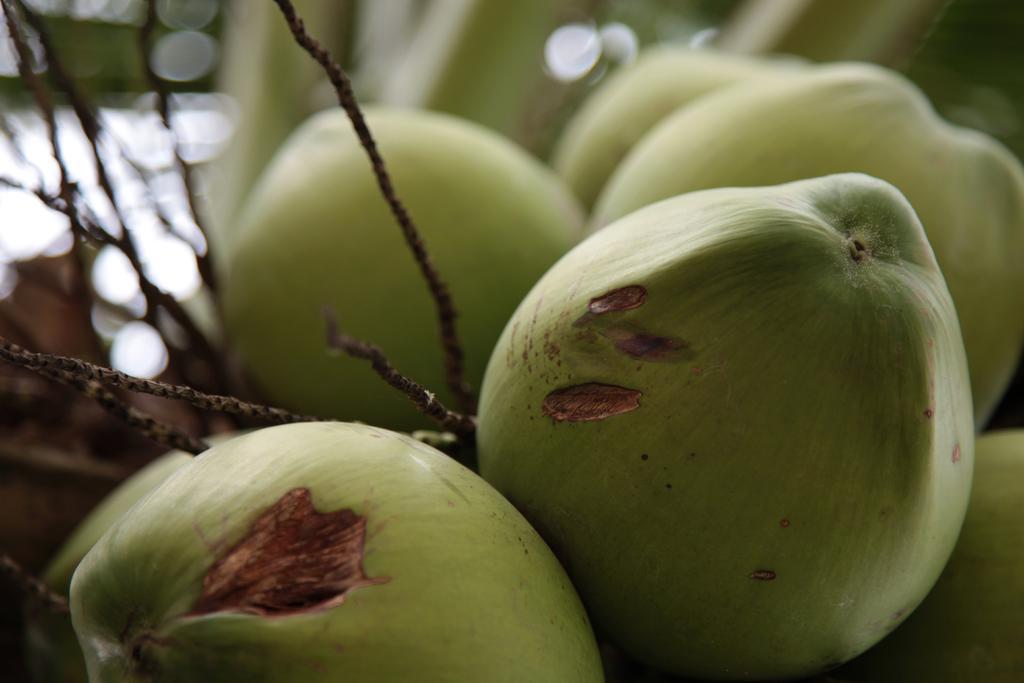Can you describe this image briefly? In this image we can see few coconuts. The background of the image is blurred. 